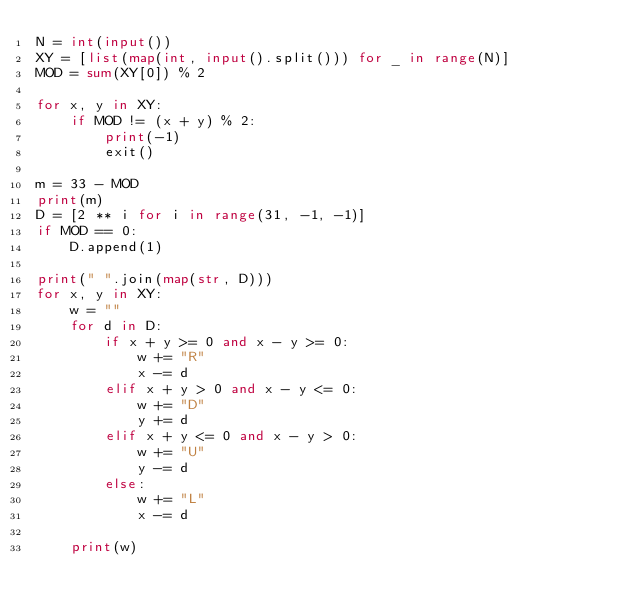Convert code to text. <code><loc_0><loc_0><loc_500><loc_500><_Python_>N = int(input())
XY = [list(map(int, input().split())) for _ in range(N)]
MOD = sum(XY[0]) % 2

for x, y in XY:
    if MOD != (x + y) % 2:
        print(-1)
        exit()

m = 33 - MOD
print(m)
D = [2 ** i for i in range(31, -1, -1)]
if MOD == 0:
    D.append(1)

print(" ".join(map(str, D)))
for x, y in XY:
    w = ""
    for d in D:
        if x + y >= 0 and x - y >= 0:
            w += "R"
            x -= d
        elif x + y > 0 and x - y <= 0:
            w += "D"
            y += d
        elif x + y <= 0 and x - y > 0:
            w += "U"
            y -= d
        else:
            w += "L"
            x -= d

    print(w)
</code> 